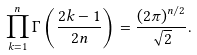<formula> <loc_0><loc_0><loc_500><loc_500>\prod _ { k = 1 } ^ { n } \Gamma \left ( \frac { 2 k - 1 } { 2 n } \right ) = \frac { ( 2 \pi ) ^ { n / 2 } } { \sqrt { 2 } } .</formula> 